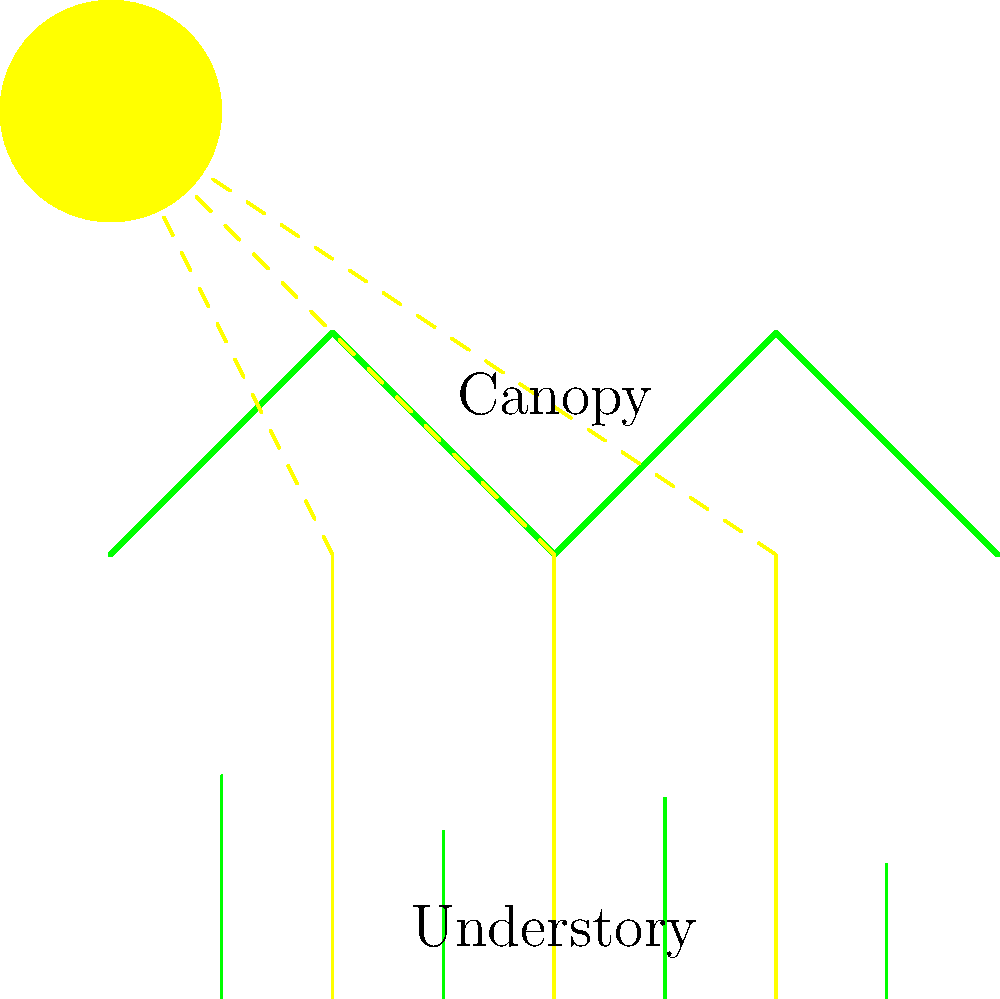In the rainforest ecosystem, sunlight diffraction through the canopy plays a crucial role in understory plant growth. If the average leaf gap in the canopy is 0.5 mm and the wavelength of red light is 650 nm, what is the approximate angle of the first diffraction maximum for red light passing through these gaps? How might this affect the distribution of light reaching understory plants? To solve this problem, we'll use the equation for single-slit diffraction and apply it to the scenario of light passing through small gaps in the forest canopy:

1. The equation for the angle of the first diffraction maximum is:
   $$\sin \theta = \frac{\lambda}{d}$$
   where $\theta$ is the angle of diffraction, $\lambda$ is the wavelength of light, and $d$ is the width of the slit (or in this case, the leaf gap).

2. We are given:
   $\lambda = 650 \text{ nm} = 6.50 \times 10^{-7} \text{ m}$
   $d = 0.5 \text{ mm} = 5.0 \times 10^{-4} \text{ m}$

3. Substituting these values into the equation:
   $$\sin \theta = \frac{6.50 \times 10^{-7}}{5.0 \times 10^{-4}} = 1.30 \times 10^{-3}$$

4. To find $\theta$, we take the inverse sine (arcsin):
   $$\theta = \arcsin(1.30 \times 10^{-3}) \approx 0.0745 \text{ radians}$$

5. Converting to degrees:
   $$\theta \approx 0.0745 \times \frac{180°}{\pi} \approx 4.27°$$

6. Effect on understory plants:
   This small angle of diffraction means that red light will spread out slightly as it passes through gaps in the canopy. This diffraction helps to distribute light more evenly in the understory, allowing plants to receive some light even when not directly under a gap. However, the intensity of light decreases as it spreads, so understory plants still receive significantly less light than those in direct sunlight.

   The diffraction effect is more pronounced for shorter wavelengths (e.g., blue light), which means that the light reaching the forest floor is slightly enriched in longer wavelengths (red and far-red). This spectral composition can influence plant growth and development, affecting processes such as germination, elongation, and flowering in understory species.
Answer: 4.27°; diffraction distributes light more evenly in understory, enriching longer wavelengths. 